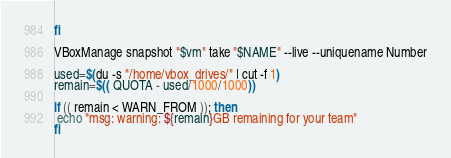<code> <loc_0><loc_0><loc_500><loc_500><_Bash_>fi

VBoxManage snapshot "$vm" take "$NAME" --live --uniquename Number

used=$(du -s "/home/vbox_drives/" | cut -f 1)
remain=$(( QUOTA - used/1000/1000))

if (( remain < WARN_FROM )); then
 echo "msg: warning: ${remain}GB remaining for your team"
fi
</code> 